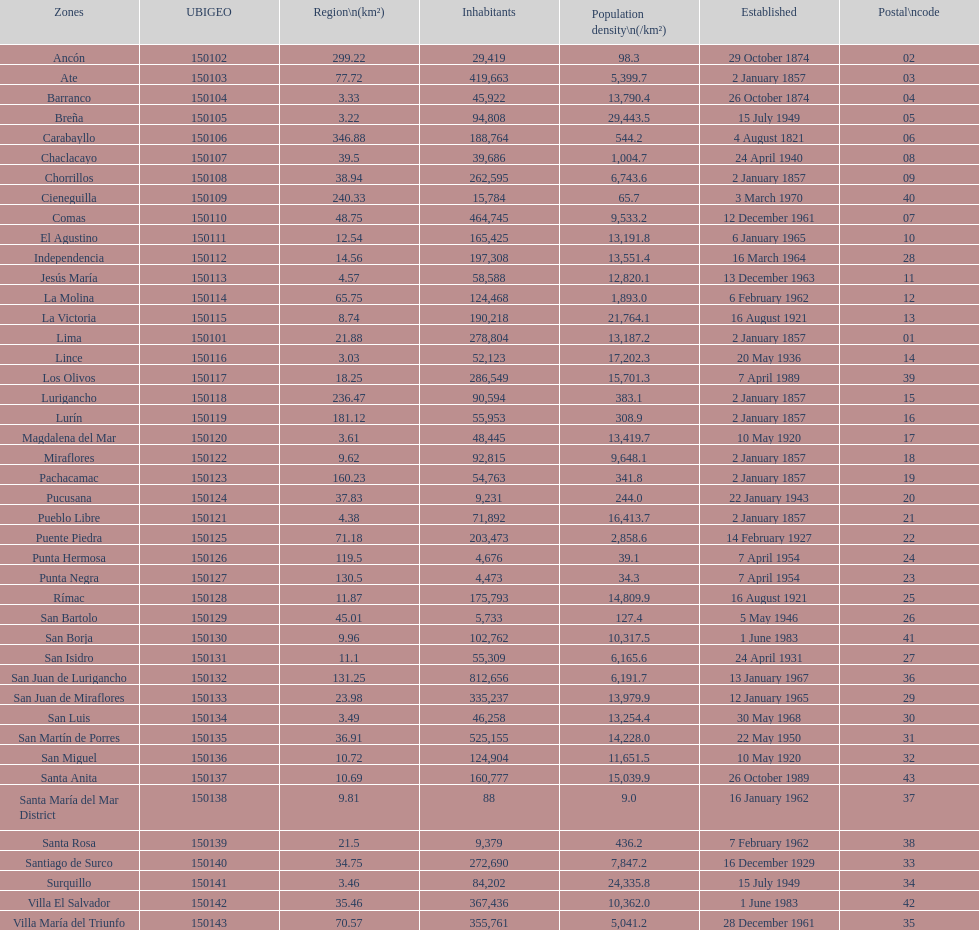How many districts are there in this city? 43. 